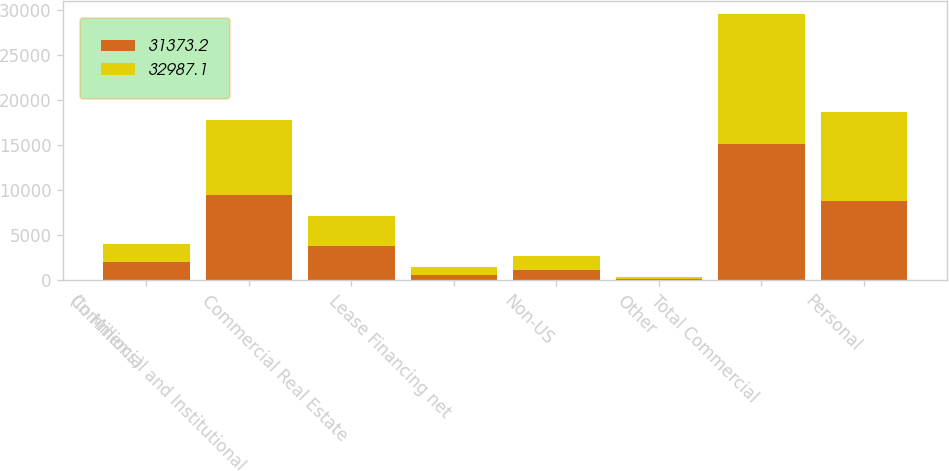Convert chart to OTSL. <chart><loc_0><loc_0><loc_500><loc_500><stacked_bar_chart><ecel><fcel>(In Millions)<fcel>Commercial and Institutional<fcel>Commercial Real Estate<fcel>Lease Financing net<fcel>Non-US<fcel>Other<fcel>Total Commercial<fcel>Personal<nl><fcel>31373.2<fcel>2015<fcel>9431.5<fcel>3848.8<fcel>544.4<fcel>1137.7<fcel>194.1<fcel>15156.5<fcel>8850.7<nl><fcel>32987.1<fcel>2014<fcel>8381.9<fcel>3333.3<fcel>916.3<fcel>1530.6<fcel>191.5<fcel>14353.6<fcel>9782.6<nl></chart> 